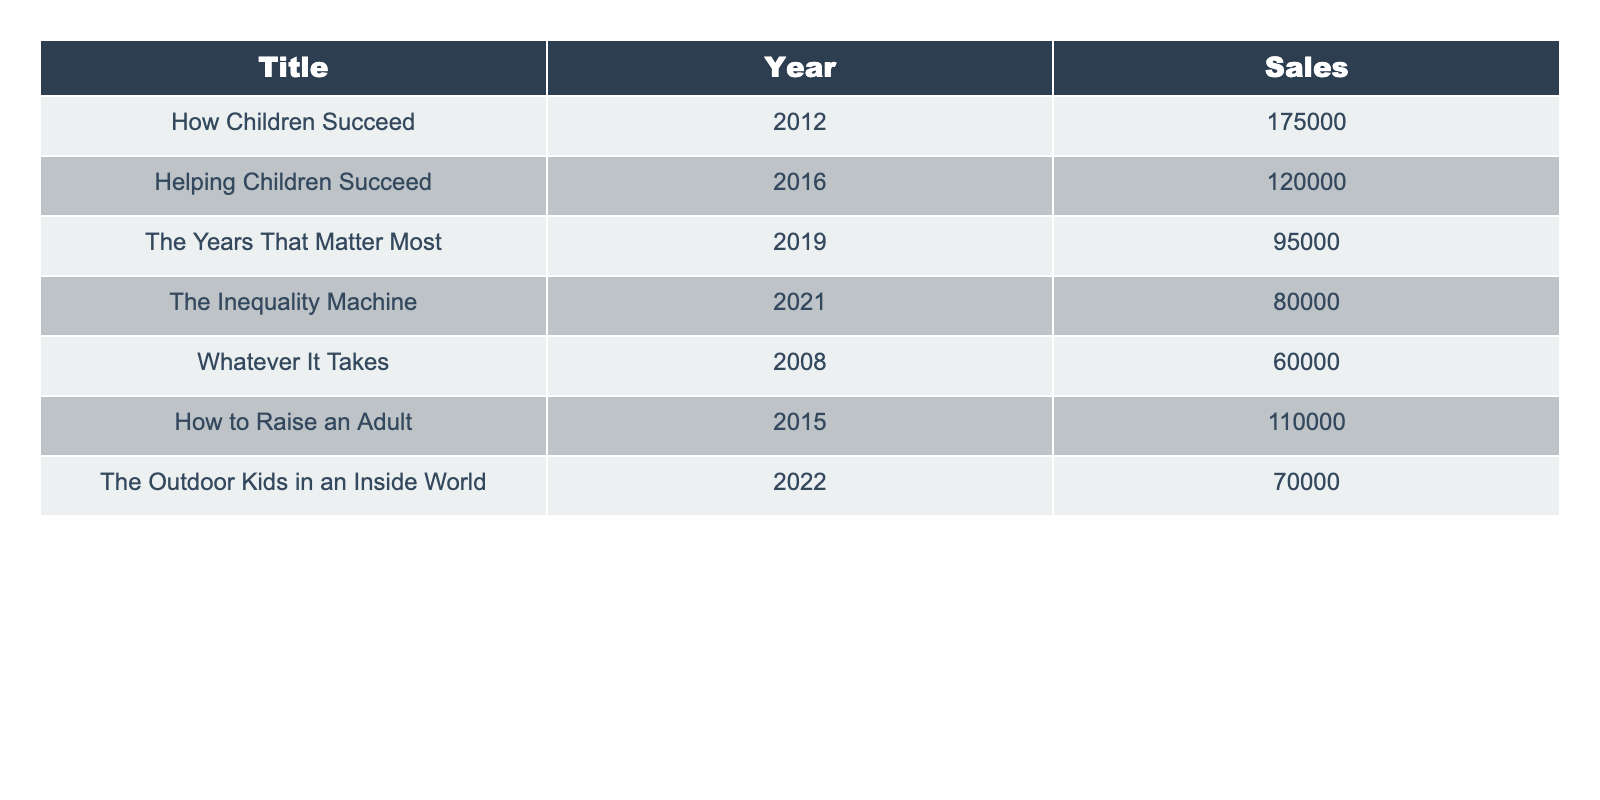What is the title of the book with the highest sales? By reviewing the sales figures in the table, we can see that "How Children Succeed" has the highest sales at 175,000.
Answer: How Children Succeed Which book had the lowest sales in 2021? When looking at the sales figures for 2021, "The Inequality Machine" had the lowest sales with 80,000.
Answer: The Inequality Machine How many copies did "How to Raise an Adult" sell? The table shows that "How to Raise an Adult" sold 110,000 copies.
Answer: 110000 What is the total number of books sold across all titles listed? To find the total sales, sum the sales for all entries: 175000 + 120000 + 95000 + 80000 + 60000 + 110000 + 70000 =  810000.
Answer: 810000 Is it true that "Helping Children Succeed" sold more copies than "The Years That Matter Most"? Comparing sales figures, "Helping Children Succeed" sold 120,000, which is greater than "The Years That Matter Most," which sold 95,000. So the statement is true.
Answer: Yes Which year saw the release of the book that sold 70,000 copies? Looking at the table, "The Outdoor Kids in an Inside World" sold 70,000 copies and was published in 2022.
Answer: 2022 What is the average sales figure for the books published before 2015? The books published before 2015 are "Whatever It Takes" (60,000), "How Children Succeed" (175,000), and "How to Raise an Adult" (110,000). The average is (60000 + 175000 + 110000) / 3 = 113,333.33.
Answer: 113333.33 How many books sold over 100,000 copies? From the table, the titles with sales over 100,000 copies are "How Children Succeed" (175,000), "Helping Children Succeed" (120,000), and "How to Raise an Adult" (110,000), totaling three books.
Answer: 3 Which books had sales figures less than 80,000? In reviewing the table, the only title with sales less than 80,000 is "The Inequality Machine" (80,000) and "Whatever It Takes" (60,000). Therefore, the only one below is "Whatever It Takes".
Answer: Whatever It Takes 